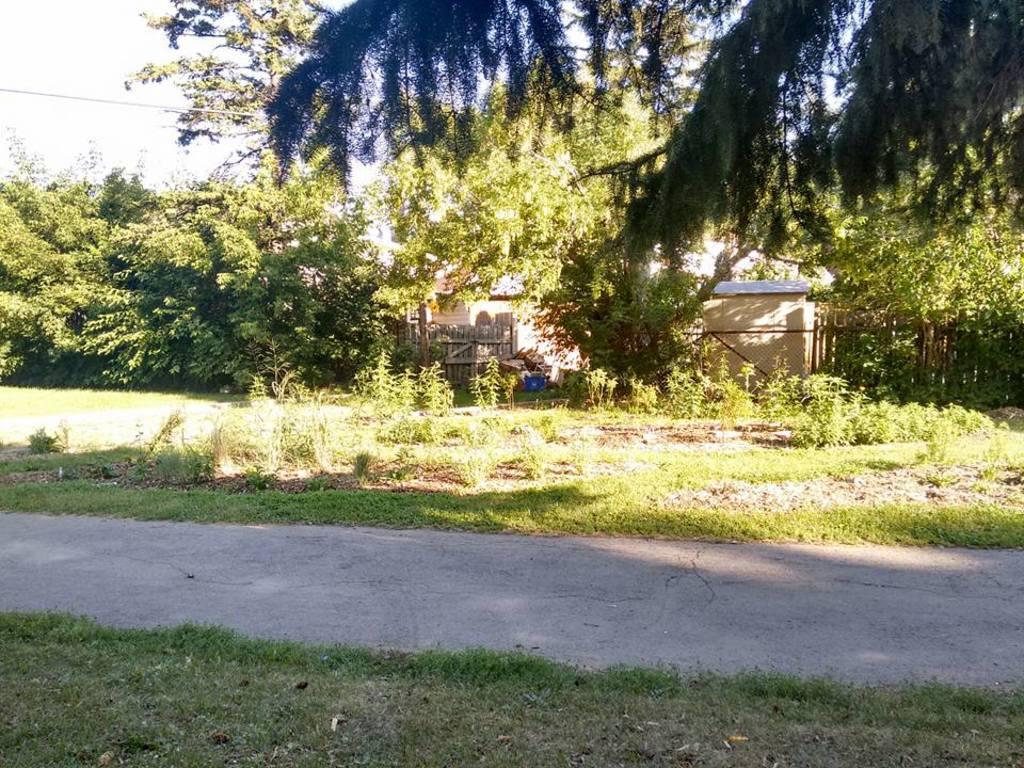In one or two sentences, can you explain what this image depicts? In the foreground of this image, there is a path and on either side, there is the grass. In the background, there are few houses, trees and the sky. 